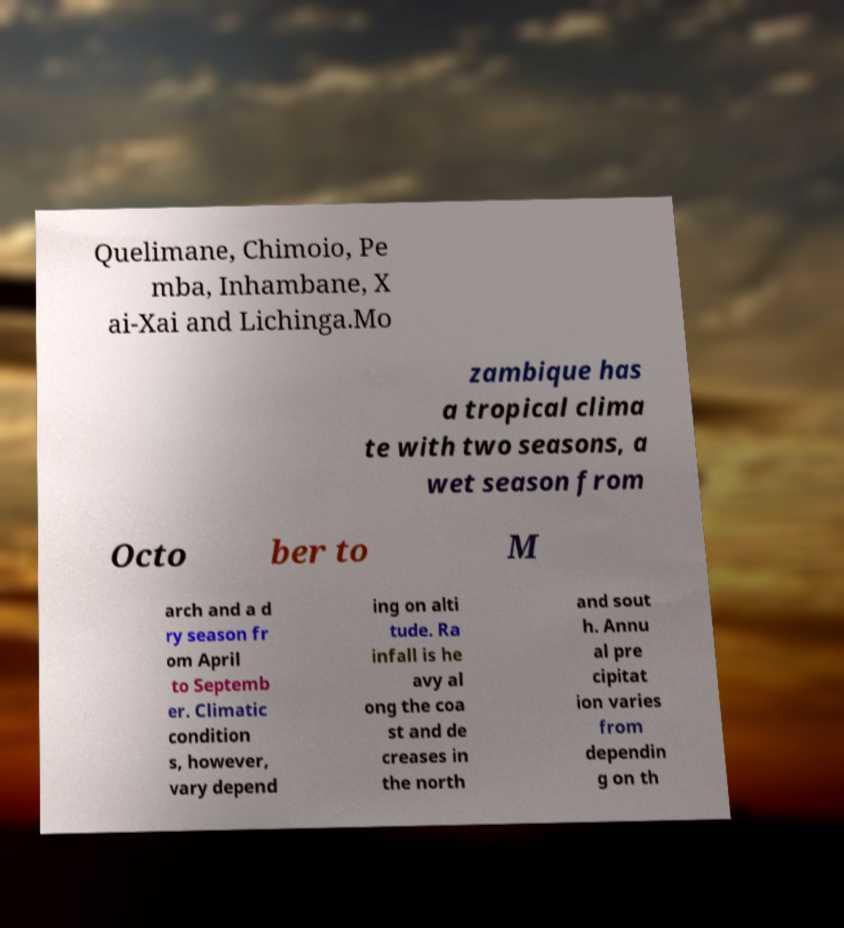Could you assist in decoding the text presented in this image and type it out clearly? Quelimane, Chimoio, Pe mba, Inhambane, X ai-Xai and Lichinga.Mo zambique has a tropical clima te with two seasons, a wet season from Octo ber to M arch and a d ry season fr om April to Septemb er. Climatic condition s, however, vary depend ing on alti tude. Ra infall is he avy al ong the coa st and de creases in the north and sout h. Annu al pre cipitat ion varies from dependin g on th 